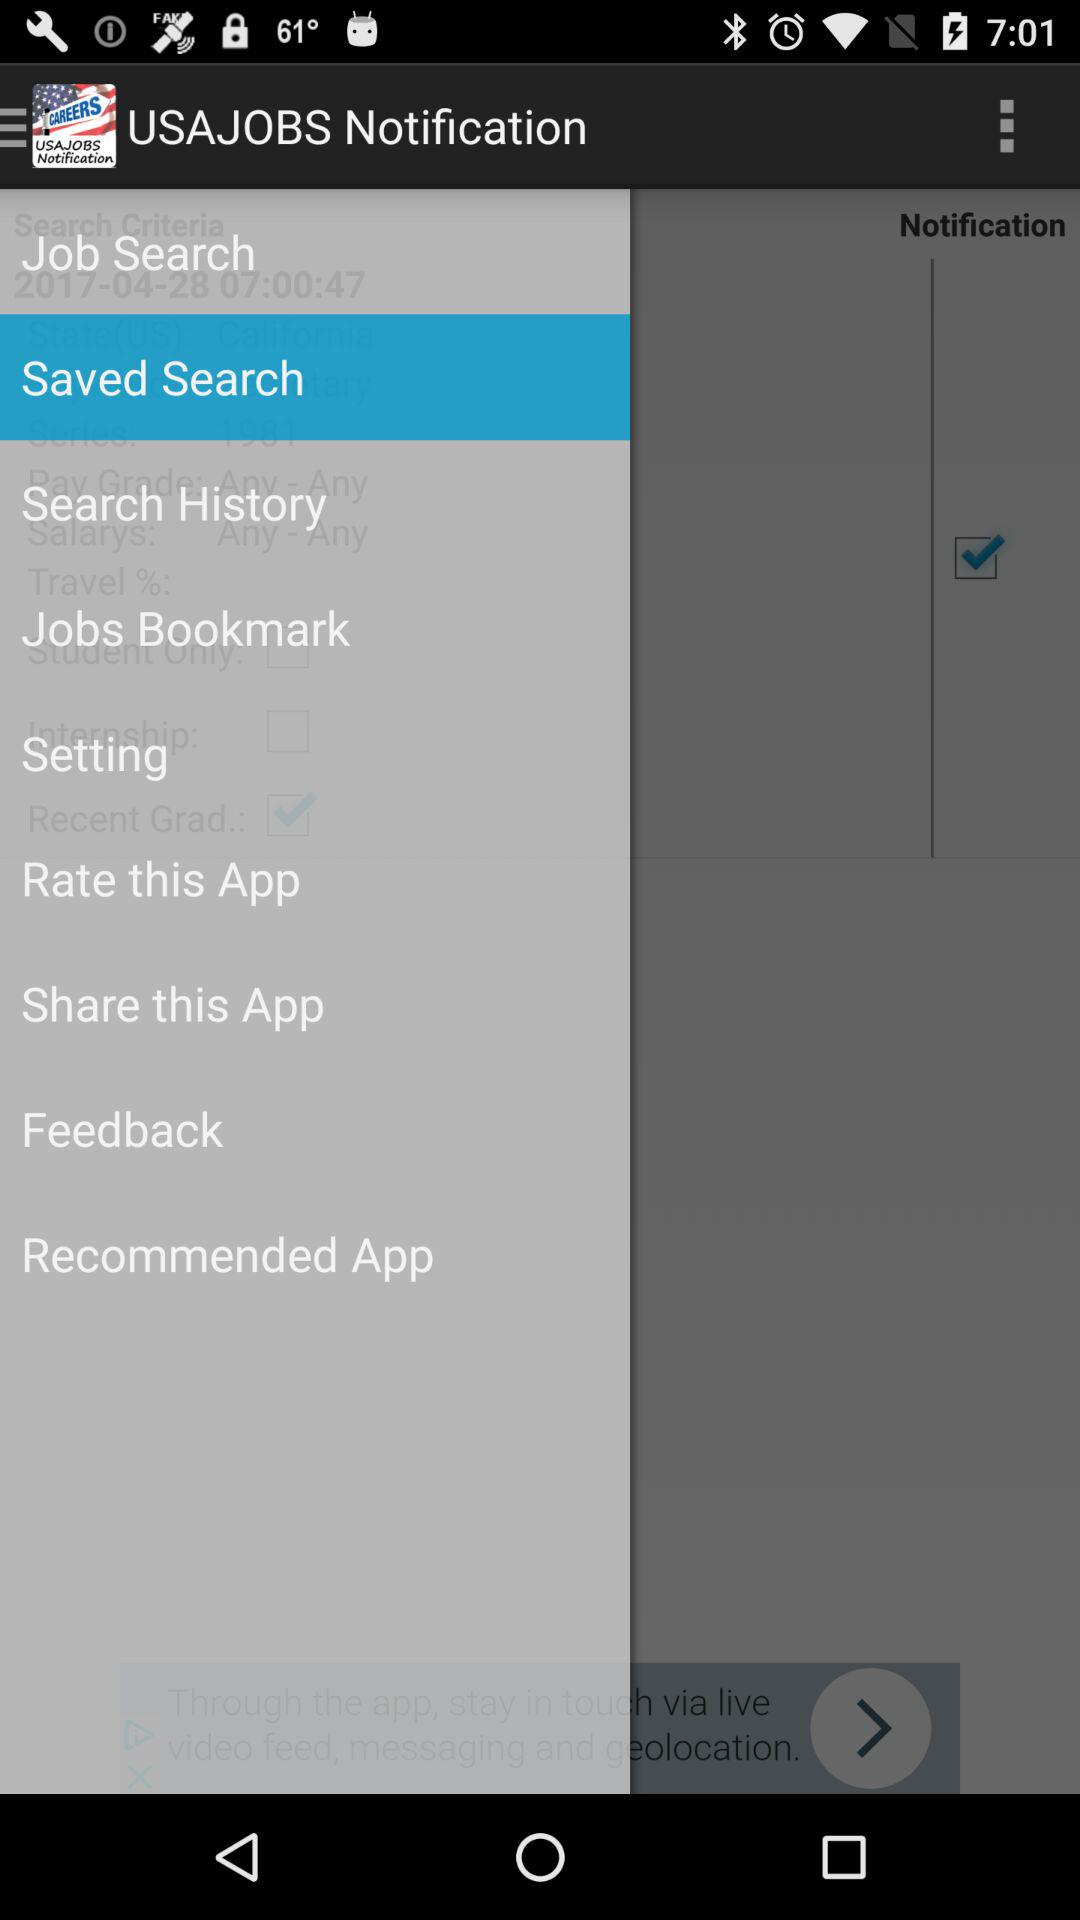Which option has been selected? The selected option is "Saved Search". 